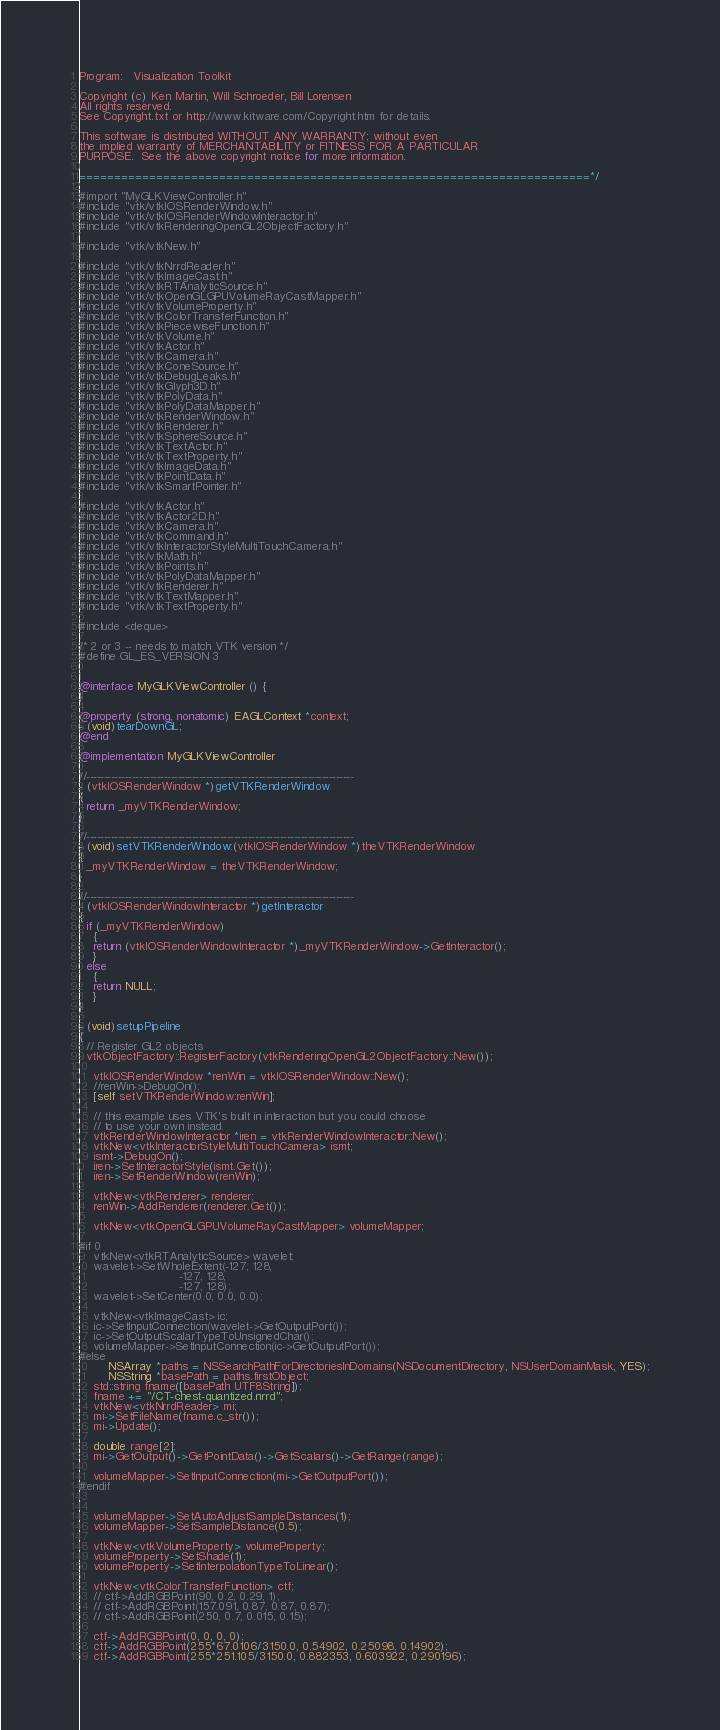<code> <loc_0><loc_0><loc_500><loc_500><_ObjectiveC_>Program:   Visualization Toolkit

Copyright (c) Ken Martin, Will Schroeder, Bill Lorensen
All rights reserved.
See Copyright.txt or http://www.kitware.com/Copyright.htm for details.

This software is distributed WITHOUT ANY WARRANTY; without even
the implied warranty of MERCHANTABILITY or FITNESS FOR A PARTICULAR
PURPOSE.  See the above copyright notice for more information.

=========================================================================*/

#import "MyGLKViewController.h"
#include "vtk/vtkIOSRenderWindow.h"
#include "vtk/vtkIOSRenderWindowInteractor.h"
#include "vtk/vtkRenderingOpenGL2ObjectFactory.h"

#include "vtk/vtkNew.h"

#include "vtk/vtkNrrdReader.h"
#include "vtk/vtkImageCast.h"
#include "vtk/vtkRTAnalyticSource.h"
#include "vtk/vtkOpenGLGPUVolumeRayCastMapper.h"
#include "vtk/vtkVolumeProperty.h"
#include "vtk/vtkColorTransferFunction.h"
#include "vtk/vtkPiecewiseFunction.h"
#include "vtk/vtkVolume.h"
#include "vtk/vtkActor.h"
#include "vtk/vtkCamera.h"
#include "vtk/vtkConeSource.h"
#include "vtk/vtkDebugLeaks.h"
#include "vtk/vtkGlyph3D.h"
#include "vtk/vtkPolyData.h"
#include "vtk/vtkPolyDataMapper.h"
#include "vtk/vtkRenderWindow.h"
#include "vtk/vtkRenderer.h"
#include "vtk/vtkSphereSource.h"
#include "vtk/vtkTextActor.h"
#include "vtk/vtkTextProperty.h"
#include "vtk/vtkImageData.h"
#include "vtk/vtkPointData.h"
#include "vtk/vtkSmartPointer.h"

#include "vtk/vtkActor.h"
#include "vtk/vtkActor2D.h"
#include "vtk/vtkCamera.h"
#include "vtk/vtkCommand.h"
#include "vtk/vtkInteractorStyleMultiTouchCamera.h"
#include "vtk/vtkMath.h"
#include "vtk/vtkPoints.h"
#include "vtk/vtkPolyDataMapper.h"
#include "vtk/vtkRenderer.h"
#include "vtk/vtkTextMapper.h"
#include "vtk/vtkTextProperty.h"

#include <deque>

/* 2 or 3 -- needs to match VTK version */
#define GL_ES_VERSION 3


@interface MyGLKViewController () {
}

@property (strong, nonatomic) EAGLContext *context;
- (void)tearDownGL;
@end

@implementation MyGLKViewController

//----------------------------------------------------------------------------
- (vtkIOSRenderWindow *)getVTKRenderWindow
{
  return _myVTKRenderWindow;
}

//----------------------------------------------------------------------------
- (void)setVTKRenderWindow:(vtkIOSRenderWindow *)theVTKRenderWindow
{
  _myVTKRenderWindow = theVTKRenderWindow;
}

//----------------------------------------------------------------------------
- (vtkIOSRenderWindowInteractor *)getInteractor
{
  if (_myVTKRenderWindow)
    {
    return (vtkIOSRenderWindowInteractor *)_myVTKRenderWindow->GetInteractor();
    }
  else
    {
    return NULL;
    }
}

- (void)setupPipeline
{
  // Register GL2 objects
  vtkObjectFactory::RegisterFactory(vtkRenderingOpenGL2ObjectFactory::New());

    vtkIOSRenderWindow *renWin = vtkIOSRenderWindow::New();
    //renWin->DebugOn();
    [self setVTKRenderWindow:renWin];

    // this example uses VTK's built in interaction but you could choose
    // to use your own instead.
    vtkRenderWindowInteractor *iren = vtkRenderWindowInteractor::New();
    vtkNew<vtkInteractorStyleMultiTouchCamera> ismt;
    ismt->DebugOn();
    iren->SetInteractorStyle(ismt.Get());
    iren->SetRenderWindow(renWin);

    vtkNew<vtkRenderer> renderer;
    renWin->AddRenderer(renderer.Get());

    vtkNew<vtkOpenGLGPUVolumeRayCastMapper> volumeMapper;

#if 0
    vtkNew<vtkRTAnalyticSource> wavelet;
    wavelet->SetWholeExtent(-127, 128,
                            -127, 128,
                            -127, 128);
    wavelet->SetCenter(0.0, 0.0, 0.0);

    vtkNew<vtkImageCast> ic;
    ic->SetInputConnection(wavelet->GetOutputPort());
    ic->SetOutputScalarTypeToUnsignedChar();
    volumeMapper->SetInputConnection(ic->GetOutputPort());
#else
        NSArray *paths = NSSearchPathForDirectoriesInDomains(NSDocumentDirectory, NSUserDomainMask, YES);
        NSString *basePath = paths.firstObject;
    std::string fname([basePath UTF8String]);
    fname += "/CT-chest-quantized.nrrd";
    vtkNew<vtkNrrdReader> mi;
    mi->SetFileName(fname.c_str());
    mi->Update();

    double range[2];
    mi->GetOutput()->GetPointData()->GetScalars()->GetRange(range);

    volumeMapper->SetInputConnection(mi->GetOutputPort());
#endif


    volumeMapper->SetAutoAdjustSampleDistances(1);
    volumeMapper->SetSampleDistance(0.5);

    vtkNew<vtkVolumeProperty> volumeProperty;
    volumeProperty->SetShade(1);
    volumeProperty->SetInterpolationTypeToLinear();

    vtkNew<vtkColorTransferFunction> ctf;
    // ctf->AddRGBPoint(90, 0.2, 0.29, 1);
    // ctf->AddRGBPoint(157.091, 0.87, 0.87, 0.87);
    // ctf->AddRGBPoint(250, 0.7, 0.015, 0.15);

    ctf->AddRGBPoint(0, 0, 0, 0);
    ctf->AddRGBPoint(255*67.0106/3150.0, 0.54902, 0.25098, 0.14902);
    ctf->AddRGBPoint(255*251.105/3150.0, 0.882353, 0.603922, 0.290196);</code> 